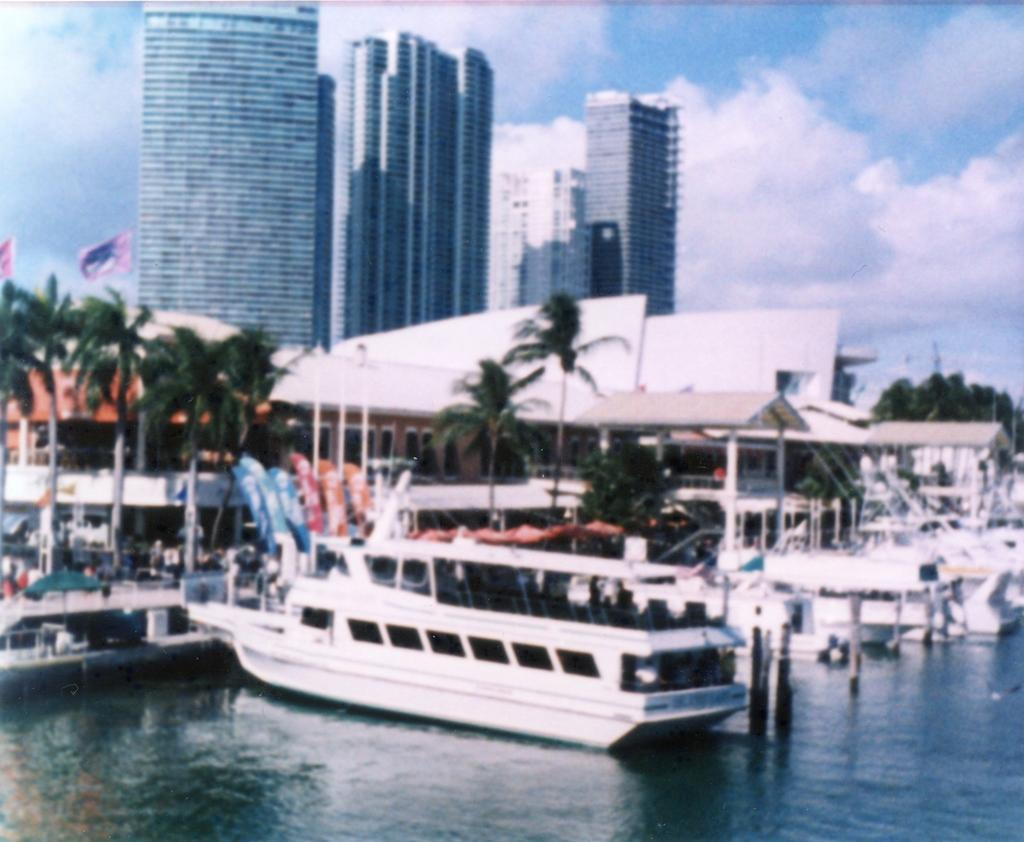What type of structures can be seen in the image? There are buildings in the image. What other natural elements are present in the image? There are trees in the image. What can be seen in the water in the image? There are boats in the water in the image. Are there any symbols or markers visible in the image? Yes, there are flags in the image. How would you describe the weather based on the sky in the image? The sky is blue and cloudy in the image, suggesting partly cloudy weather. What type of mint is growing near the buildings in the image? There is no mint present in the image; it features buildings, trees, boats, flags, and a blue, cloudy sky. 